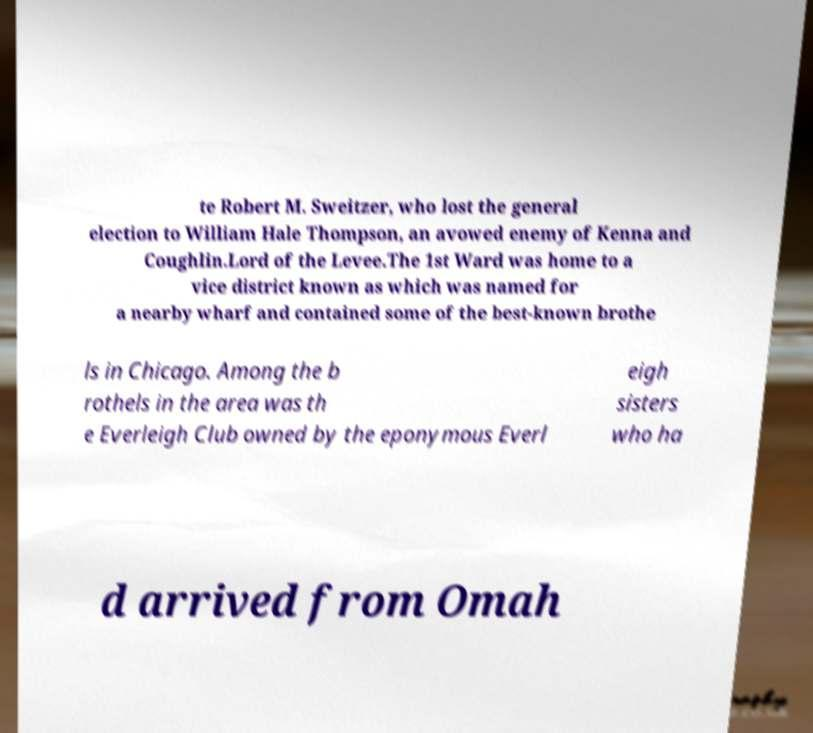Please identify and transcribe the text found in this image. te Robert M. Sweitzer, who lost the general election to William Hale Thompson, an avowed enemy of Kenna and Coughlin.Lord of the Levee.The 1st Ward was home to a vice district known as which was named for a nearby wharf and contained some of the best-known brothe ls in Chicago. Among the b rothels in the area was th e Everleigh Club owned by the eponymous Everl eigh sisters who ha d arrived from Omah 